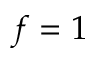<formula> <loc_0><loc_0><loc_500><loc_500>f = 1</formula> 